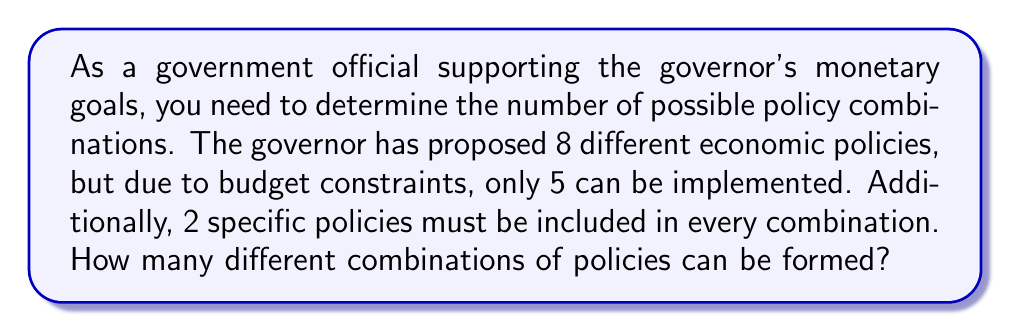What is the answer to this math problem? Let's approach this step-by-step:

1) We have 8 total policies, and 2 of them must be included in every combination. This means we're really choosing from the remaining 6 policies to fill the other 3 spots.

2) We can frame this as a combination problem. We're selecting 3 policies from 6 options, where the order doesn't matter.

3) The formula for combinations is:

   $$C(n,r) = \frac{n!}{r!(n-r)!}$$

   Where $n$ is the total number of items to choose from, and $r$ is the number of items being chosen.

4) In this case, $n = 6$ and $r = 3$. Let's substitute these values:

   $$C(6,3) = \frac{6!}{3!(6-3)!} = \frac{6!}{3!3!}$$

5) Expand this:
   
   $$\frac{6 * 5 * 4 * 3!}{3 * 2 * 1 * 3!}$$

6) The $3!$ cancels out in the numerator and denominator:

   $$\frac{6 * 5 * 4}{3 * 2 * 1} = \frac{120}{6} = 20$$

Therefore, there are 20 possible combinations of policies that satisfy the given constraints.
Answer: 20 